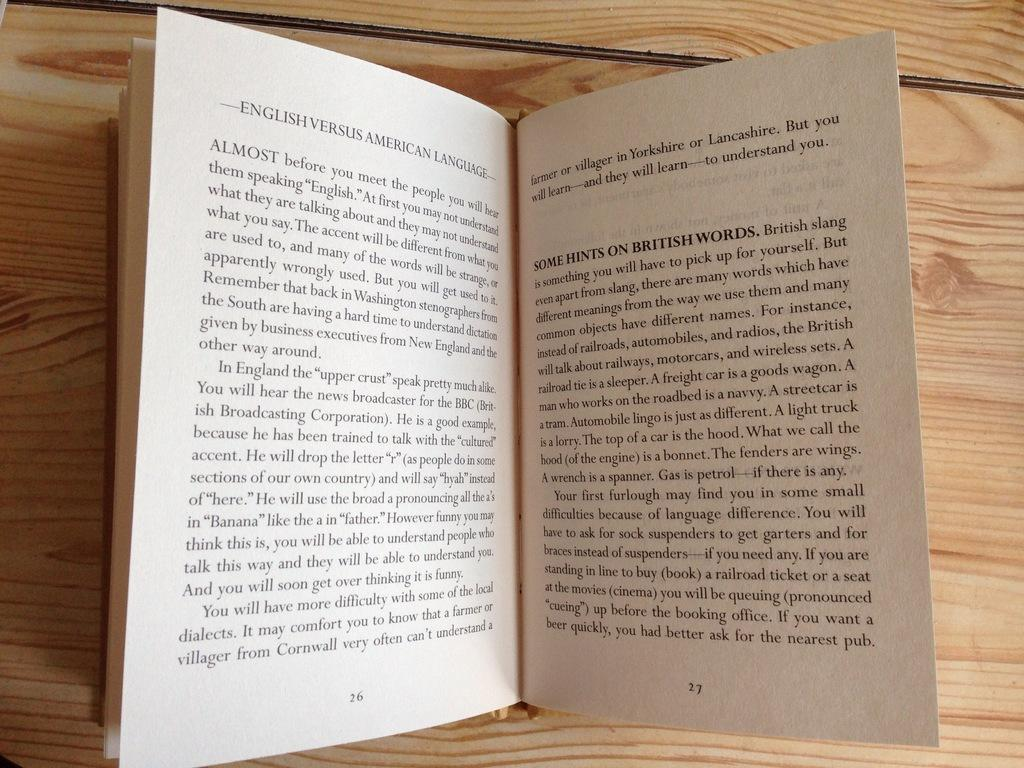<image>
Render a clear and concise summary of the photo. Pages of a book about English versus American language 